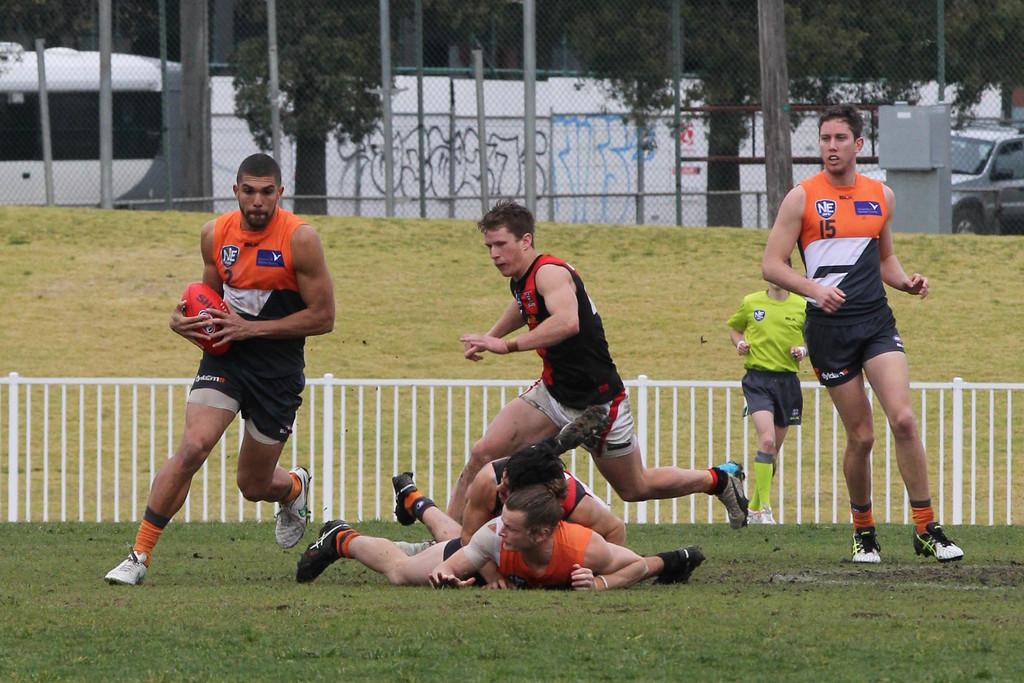What number is the guy wearing with the ball?
Give a very brief answer. 2. What number is the player on the right?
Keep it short and to the point. 15. 